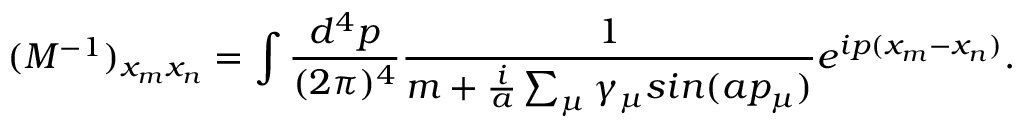Convert formula to latex. <formula><loc_0><loc_0><loc_500><loc_500>( M ^ { - 1 } ) _ { x _ { m } x _ { n } } = \int \frac { d ^ { 4 } p } { ( 2 { \pi } ) ^ { 4 } } \frac { 1 } { m + \frac { i } { a } \sum _ { \mu } { \gamma } _ { \mu } \sin ( a p _ { \mu } ) } e ^ { i p ( x _ { m } - x _ { n } ) } .</formula> 